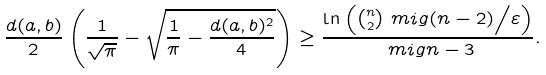<formula> <loc_0><loc_0><loc_500><loc_500>\frac { d ( a , b ) } { 2 } \left ( \frac { 1 } { \sqrt { \pi } } - \sqrt { \frac { 1 } { \pi } - \frac { d ( a , b ) ^ { 2 } } { 4 } } \right ) & \geq \frac { \ln \left ( \binom { n } { 2 } \ m i g { ( n - 2 ) } \Big / \varepsilon \right ) } { \ m i g { n - 3 } } .</formula> 